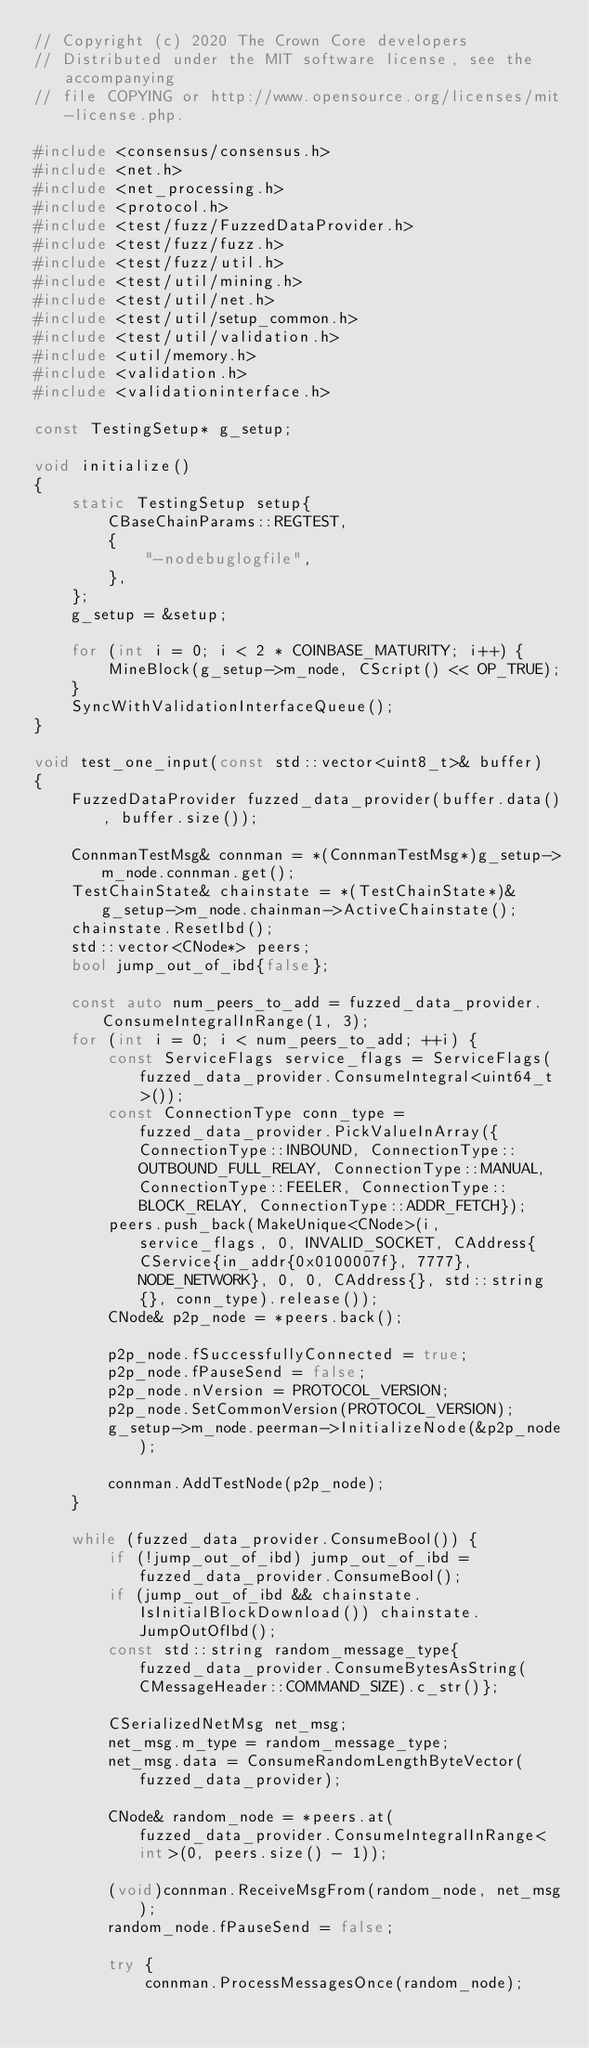Convert code to text. <code><loc_0><loc_0><loc_500><loc_500><_C++_>// Copyright (c) 2020 The Crown Core developers
// Distributed under the MIT software license, see the accompanying
// file COPYING or http://www.opensource.org/licenses/mit-license.php.

#include <consensus/consensus.h>
#include <net.h>
#include <net_processing.h>
#include <protocol.h>
#include <test/fuzz/FuzzedDataProvider.h>
#include <test/fuzz/fuzz.h>
#include <test/fuzz/util.h>
#include <test/util/mining.h>
#include <test/util/net.h>
#include <test/util/setup_common.h>
#include <test/util/validation.h>
#include <util/memory.h>
#include <validation.h>
#include <validationinterface.h>

const TestingSetup* g_setup;

void initialize()
{
    static TestingSetup setup{
        CBaseChainParams::REGTEST,
        {
            "-nodebuglogfile",
        },
    };
    g_setup = &setup;

    for (int i = 0; i < 2 * COINBASE_MATURITY; i++) {
        MineBlock(g_setup->m_node, CScript() << OP_TRUE);
    }
    SyncWithValidationInterfaceQueue();
}

void test_one_input(const std::vector<uint8_t>& buffer)
{
    FuzzedDataProvider fuzzed_data_provider(buffer.data(), buffer.size());

    ConnmanTestMsg& connman = *(ConnmanTestMsg*)g_setup->m_node.connman.get();
    TestChainState& chainstate = *(TestChainState*)&g_setup->m_node.chainman->ActiveChainstate();
    chainstate.ResetIbd();
    std::vector<CNode*> peers;
    bool jump_out_of_ibd{false};

    const auto num_peers_to_add = fuzzed_data_provider.ConsumeIntegralInRange(1, 3);
    for (int i = 0; i < num_peers_to_add; ++i) {
        const ServiceFlags service_flags = ServiceFlags(fuzzed_data_provider.ConsumeIntegral<uint64_t>());
        const ConnectionType conn_type = fuzzed_data_provider.PickValueInArray({ConnectionType::INBOUND, ConnectionType::OUTBOUND_FULL_RELAY, ConnectionType::MANUAL, ConnectionType::FEELER, ConnectionType::BLOCK_RELAY, ConnectionType::ADDR_FETCH});
        peers.push_back(MakeUnique<CNode>(i, service_flags, 0, INVALID_SOCKET, CAddress{CService{in_addr{0x0100007f}, 7777}, NODE_NETWORK}, 0, 0, CAddress{}, std::string{}, conn_type).release());
        CNode& p2p_node = *peers.back();

        p2p_node.fSuccessfullyConnected = true;
        p2p_node.fPauseSend = false;
        p2p_node.nVersion = PROTOCOL_VERSION;
        p2p_node.SetCommonVersion(PROTOCOL_VERSION);
        g_setup->m_node.peerman->InitializeNode(&p2p_node);

        connman.AddTestNode(p2p_node);
    }

    while (fuzzed_data_provider.ConsumeBool()) {
        if (!jump_out_of_ibd) jump_out_of_ibd = fuzzed_data_provider.ConsumeBool();
        if (jump_out_of_ibd && chainstate.IsInitialBlockDownload()) chainstate.JumpOutOfIbd();
        const std::string random_message_type{fuzzed_data_provider.ConsumeBytesAsString(CMessageHeader::COMMAND_SIZE).c_str()};

        CSerializedNetMsg net_msg;
        net_msg.m_type = random_message_type;
        net_msg.data = ConsumeRandomLengthByteVector(fuzzed_data_provider);

        CNode& random_node = *peers.at(fuzzed_data_provider.ConsumeIntegralInRange<int>(0, peers.size() - 1));

        (void)connman.ReceiveMsgFrom(random_node, net_msg);
        random_node.fPauseSend = false;

        try {
            connman.ProcessMessagesOnce(random_node);</code> 